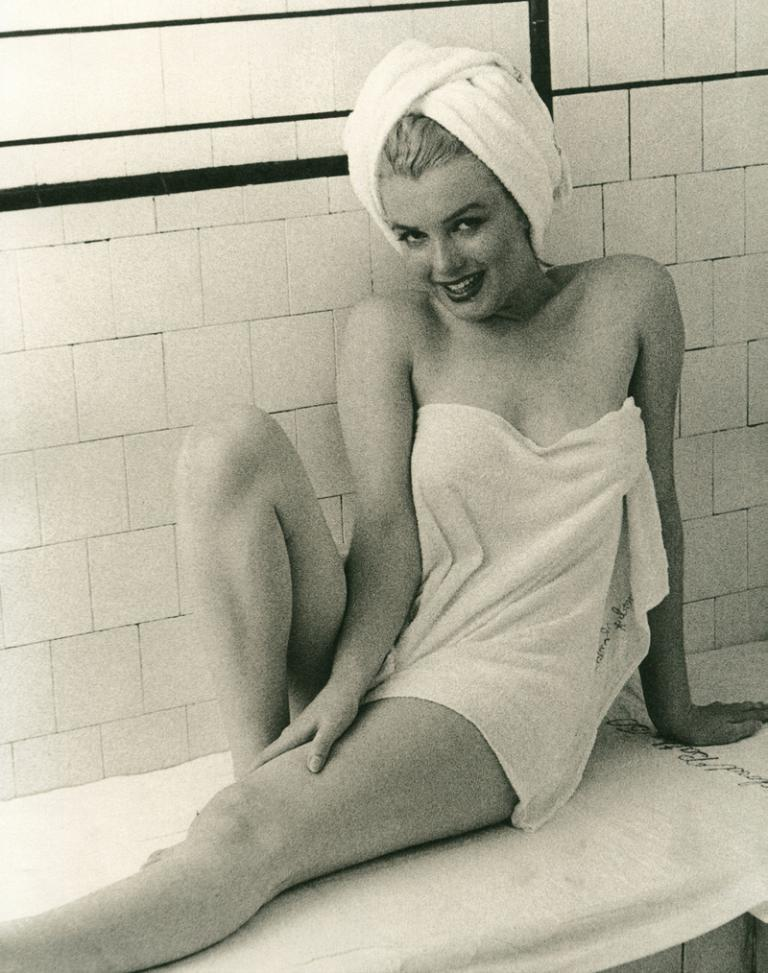Who is present in the image? There is a woman in the image. What is the woman doing in the image? The woman is sitting on the bed. What can be seen in the background of the image? There is a wall in the background of the image. What type of steam is coming out of the woman's finger in the image? There is no steam or finger present in the image; it only features a woman sitting on the bed with a wall in the background. 